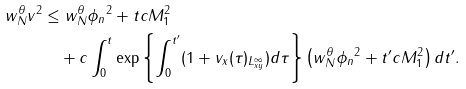<formula> <loc_0><loc_0><loc_500><loc_500>\| w _ { N } ^ { \theta } v \| ^ { 2 } & \leq \| w _ { N } ^ { \theta } \phi _ { n } \| ^ { 2 } + t c M _ { 1 } ^ { 2 } \\ & \quad + c \int _ { 0 } ^ { t } \exp \left \{ \int _ { 0 } ^ { t ^ { \prime } } ( 1 + \| v _ { x } ( \tau ) \| _ { L ^ { \infty } _ { x y } } ) d \tau \right \} \left ( \| w _ { N } ^ { \theta } \phi _ { n } \| ^ { 2 } + t ^ { \prime } c M _ { 1 } ^ { 2 } \right ) d t ^ { \prime } .</formula> 